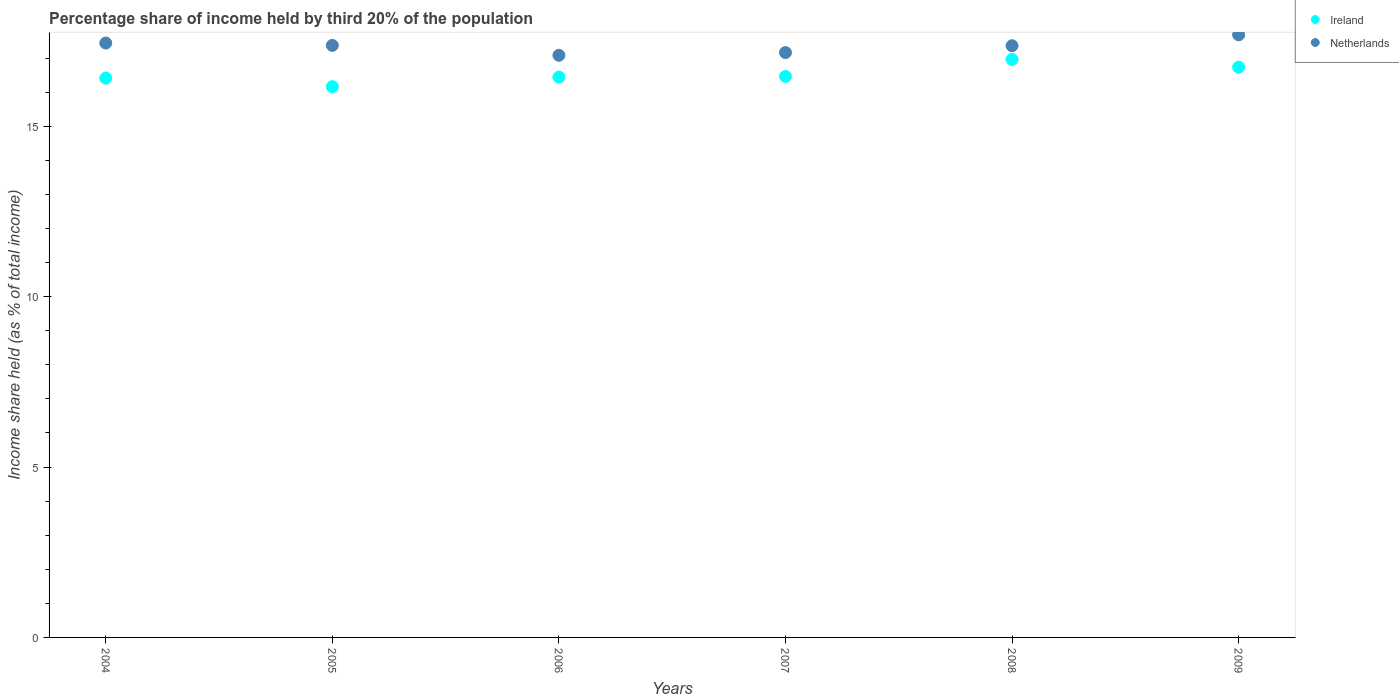How many different coloured dotlines are there?
Provide a short and direct response. 2. Is the number of dotlines equal to the number of legend labels?
Provide a short and direct response. Yes. What is the share of income held by third 20% of the population in Netherlands in 2008?
Ensure brevity in your answer.  17.36. Across all years, what is the maximum share of income held by third 20% of the population in Ireland?
Make the answer very short. 16.96. Across all years, what is the minimum share of income held by third 20% of the population in Netherlands?
Keep it short and to the point. 17.08. In which year was the share of income held by third 20% of the population in Ireland maximum?
Ensure brevity in your answer.  2008. In which year was the share of income held by third 20% of the population in Ireland minimum?
Provide a short and direct response. 2005. What is the total share of income held by third 20% of the population in Netherlands in the graph?
Offer a terse response. 104.09. What is the difference between the share of income held by third 20% of the population in Netherlands in 2006 and that in 2008?
Give a very brief answer. -0.28. What is the difference between the share of income held by third 20% of the population in Netherlands in 2005 and the share of income held by third 20% of the population in Ireland in 2009?
Your answer should be very brief. 0.64. What is the average share of income held by third 20% of the population in Netherlands per year?
Provide a short and direct response. 17.35. In the year 2004, what is the difference between the share of income held by third 20% of the population in Netherlands and share of income held by third 20% of the population in Ireland?
Your answer should be compact. 1.03. In how many years, is the share of income held by third 20% of the population in Ireland greater than 16 %?
Ensure brevity in your answer.  6. What is the ratio of the share of income held by third 20% of the population in Ireland in 2004 to that in 2007?
Your answer should be very brief. 1. Is the difference between the share of income held by third 20% of the population in Netherlands in 2006 and 2007 greater than the difference between the share of income held by third 20% of the population in Ireland in 2006 and 2007?
Make the answer very short. No. What is the difference between the highest and the second highest share of income held by third 20% of the population in Netherlands?
Your answer should be compact. 0.24. What is the difference between the highest and the lowest share of income held by third 20% of the population in Netherlands?
Make the answer very short. 0.6. Is the sum of the share of income held by third 20% of the population in Netherlands in 2005 and 2007 greater than the maximum share of income held by third 20% of the population in Ireland across all years?
Your answer should be very brief. Yes. Does the share of income held by third 20% of the population in Ireland monotonically increase over the years?
Give a very brief answer. No. Is the share of income held by third 20% of the population in Netherlands strictly less than the share of income held by third 20% of the population in Ireland over the years?
Ensure brevity in your answer.  No. How many dotlines are there?
Offer a very short reply. 2. How many years are there in the graph?
Your response must be concise. 6. What is the difference between two consecutive major ticks on the Y-axis?
Offer a terse response. 5. Does the graph contain grids?
Keep it short and to the point. No. How many legend labels are there?
Offer a terse response. 2. What is the title of the graph?
Ensure brevity in your answer.  Percentage share of income held by third 20% of the population. What is the label or title of the Y-axis?
Your answer should be very brief. Income share held (as % of total income). What is the Income share held (as % of total income) of Ireland in 2004?
Make the answer very short. 16.41. What is the Income share held (as % of total income) of Netherlands in 2004?
Your answer should be compact. 17.44. What is the Income share held (as % of total income) in Ireland in 2005?
Make the answer very short. 16.16. What is the Income share held (as % of total income) in Netherlands in 2005?
Keep it short and to the point. 17.37. What is the Income share held (as % of total income) of Ireland in 2006?
Offer a very short reply. 16.44. What is the Income share held (as % of total income) of Netherlands in 2006?
Offer a very short reply. 17.08. What is the Income share held (as % of total income) in Ireland in 2007?
Offer a very short reply. 16.46. What is the Income share held (as % of total income) in Netherlands in 2007?
Provide a short and direct response. 17.16. What is the Income share held (as % of total income) in Ireland in 2008?
Ensure brevity in your answer.  16.96. What is the Income share held (as % of total income) of Netherlands in 2008?
Your answer should be compact. 17.36. What is the Income share held (as % of total income) of Ireland in 2009?
Offer a terse response. 16.73. What is the Income share held (as % of total income) in Netherlands in 2009?
Offer a terse response. 17.68. Across all years, what is the maximum Income share held (as % of total income) in Ireland?
Keep it short and to the point. 16.96. Across all years, what is the maximum Income share held (as % of total income) in Netherlands?
Keep it short and to the point. 17.68. Across all years, what is the minimum Income share held (as % of total income) in Ireland?
Your response must be concise. 16.16. Across all years, what is the minimum Income share held (as % of total income) in Netherlands?
Give a very brief answer. 17.08. What is the total Income share held (as % of total income) in Ireland in the graph?
Offer a terse response. 99.16. What is the total Income share held (as % of total income) of Netherlands in the graph?
Your response must be concise. 104.09. What is the difference between the Income share held (as % of total income) of Ireland in 2004 and that in 2005?
Your response must be concise. 0.25. What is the difference between the Income share held (as % of total income) of Netherlands in 2004 and that in 2005?
Offer a terse response. 0.07. What is the difference between the Income share held (as % of total income) of Ireland in 2004 and that in 2006?
Your answer should be very brief. -0.03. What is the difference between the Income share held (as % of total income) in Netherlands in 2004 and that in 2006?
Keep it short and to the point. 0.36. What is the difference between the Income share held (as % of total income) of Netherlands in 2004 and that in 2007?
Offer a very short reply. 0.28. What is the difference between the Income share held (as % of total income) of Ireland in 2004 and that in 2008?
Ensure brevity in your answer.  -0.55. What is the difference between the Income share held (as % of total income) of Netherlands in 2004 and that in 2008?
Give a very brief answer. 0.08. What is the difference between the Income share held (as % of total income) of Ireland in 2004 and that in 2009?
Your answer should be very brief. -0.32. What is the difference between the Income share held (as % of total income) in Netherlands in 2004 and that in 2009?
Ensure brevity in your answer.  -0.24. What is the difference between the Income share held (as % of total income) of Ireland in 2005 and that in 2006?
Your response must be concise. -0.28. What is the difference between the Income share held (as % of total income) of Netherlands in 2005 and that in 2006?
Your answer should be very brief. 0.29. What is the difference between the Income share held (as % of total income) of Netherlands in 2005 and that in 2007?
Ensure brevity in your answer.  0.21. What is the difference between the Income share held (as % of total income) of Netherlands in 2005 and that in 2008?
Your response must be concise. 0.01. What is the difference between the Income share held (as % of total income) in Ireland in 2005 and that in 2009?
Keep it short and to the point. -0.57. What is the difference between the Income share held (as % of total income) in Netherlands in 2005 and that in 2009?
Your answer should be compact. -0.31. What is the difference between the Income share held (as % of total income) in Ireland in 2006 and that in 2007?
Provide a succinct answer. -0.02. What is the difference between the Income share held (as % of total income) in Netherlands in 2006 and that in 2007?
Provide a succinct answer. -0.08. What is the difference between the Income share held (as % of total income) of Ireland in 2006 and that in 2008?
Give a very brief answer. -0.52. What is the difference between the Income share held (as % of total income) in Netherlands in 2006 and that in 2008?
Offer a very short reply. -0.28. What is the difference between the Income share held (as % of total income) of Ireland in 2006 and that in 2009?
Make the answer very short. -0.29. What is the difference between the Income share held (as % of total income) in Netherlands in 2006 and that in 2009?
Ensure brevity in your answer.  -0.6. What is the difference between the Income share held (as % of total income) in Ireland in 2007 and that in 2008?
Ensure brevity in your answer.  -0.5. What is the difference between the Income share held (as % of total income) in Ireland in 2007 and that in 2009?
Your response must be concise. -0.27. What is the difference between the Income share held (as % of total income) in Netherlands in 2007 and that in 2009?
Your answer should be very brief. -0.52. What is the difference between the Income share held (as % of total income) in Ireland in 2008 and that in 2009?
Make the answer very short. 0.23. What is the difference between the Income share held (as % of total income) of Netherlands in 2008 and that in 2009?
Provide a succinct answer. -0.32. What is the difference between the Income share held (as % of total income) of Ireland in 2004 and the Income share held (as % of total income) of Netherlands in 2005?
Your response must be concise. -0.96. What is the difference between the Income share held (as % of total income) of Ireland in 2004 and the Income share held (as % of total income) of Netherlands in 2006?
Provide a succinct answer. -0.67. What is the difference between the Income share held (as % of total income) of Ireland in 2004 and the Income share held (as % of total income) of Netherlands in 2007?
Your answer should be very brief. -0.75. What is the difference between the Income share held (as % of total income) of Ireland in 2004 and the Income share held (as % of total income) of Netherlands in 2008?
Offer a very short reply. -0.95. What is the difference between the Income share held (as % of total income) in Ireland in 2004 and the Income share held (as % of total income) in Netherlands in 2009?
Offer a terse response. -1.27. What is the difference between the Income share held (as % of total income) in Ireland in 2005 and the Income share held (as % of total income) in Netherlands in 2006?
Your answer should be compact. -0.92. What is the difference between the Income share held (as % of total income) of Ireland in 2005 and the Income share held (as % of total income) of Netherlands in 2009?
Your response must be concise. -1.52. What is the difference between the Income share held (as % of total income) of Ireland in 2006 and the Income share held (as % of total income) of Netherlands in 2007?
Your answer should be very brief. -0.72. What is the difference between the Income share held (as % of total income) of Ireland in 2006 and the Income share held (as % of total income) of Netherlands in 2008?
Give a very brief answer. -0.92. What is the difference between the Income share held (as % of total income) in Ireland in 2006 and the Income share held (as % of total income) in Netherlands in 2009?
Your answer should be very brief. -1.24. What is the difference between the Income share held (as % of total income) in Ireland in 2007 and the Income share held (as % of total income) in Netherlands in 2008?
Provide a succinct answer. -0.9. What is the difference between the Income share held (as % of total income) in Ireland in 2007 and the Income share held (as % of total income) in Netherlands in 2009?
Your answer should be very brief. -1.22. What is the difference between the Income share held (as % of total income) in Ireland in 2008 and the Income share held (as % of total income) in Netherlands in 2009?
Keep it short and to the point. -0.72. What is the average Income share held (as % of total income) of Ireland per year?
Make the answer very short. 16.53. What is the average Income share held (as % of total income) of Netherlands per year?
Your response must be concise. 17.35. In the year 2004, what is the difference between the Income share held (as % of total income) in Ireland and Income share held (as % of total income) in Netherlands?
Provide a short and direct response. -1.03. In the year 2005, what is the difference between the Income share held (as % of total income) of Ireland and Income share held (as % of total income) of Netherlands?
Keep it short and to the point. -1.21. In the year 2006, what is the difference between the Income share held (as % of total income) of Ireland and Income share held (as % of total income) of Netherlands?
Provide a short and direct response. -0.64. In the year 2007, what is the difference between the Income share held (as % of total income) in Ireland and Income share held (as % of total income) in Netherlands?
Offer a terse response. -0.7. In the year 2009, what is the difference between the Income share held (as % of total income) of Ireland and Income share held (as % of total income) of Netherlands?
Offer a very short reply. -0.95. What is the ratio of the Income share held (as % of total income) of Ireland in 2004 to that in 2005?
Ensure brevity in your answer.  1.02. What is the ratio of the Income share held (as % of total income) of Netherlands in 2004 to that in 2005?
Offer a very short reply. 1. What is the ratio of the Income share held (as % of total income) in Ireland in 2004 to that in 2006?
Provide a short and direct response. 1. What is the ratio of the Income share held (as % of total income) in Netherlands in 2004 to that in 2006?
Keep it short and to the point. 1.02. What is the ratio of the Income share held (as % of total income) in Ireland in 2004 to that in 2007?
Give a very brief answer. 1. What is the ratio of the Income share held (as % of total income) of Netherlands in 2004 to that in 2007?
Provide a short and direct response. 1.02. What is the ratio of the Income share held (as % of total income) in Ireland in 2004 to that in 2008?
Offer a terse response. 0.97. What is the ratio of the Income share held (as % of total income) in Ireland in 2004 to that in 2009?
Provide a succinct answer. 0.98. What is the ratio of the Income share held (as % of total income) of Netherlands in 2004 to that in 2009?
Your response must be concise. 0.99. What is the ratio of the Income share held (as % of total income) of Netherlands in 2005 to that in 2006?
Offer a very short reply. 1.02. What is the ratio of the Income share held (as % of total income) in Ireland in 2005 to that in 2007?
Provide a short and direct response. 0.98. What is the ratio of the Income share held (as % of total income) in Netherlands in 2005 to that in 2007?
Provide a short and direct response. 1.01. What is the ratio of the Income share held (as % of total income) in Ireland in 2005 to that in 2008?
Keep it short and to the point. 0.95. What is the ratio of the Income share held (as % of total income) in Netherlands in 2005 to that in 2008?
Your answer should be compact. 1. What is the ratio of the Income share held (as % of total income) of Ireland in 2005 to that in 2009?
Give a very brief answer. 0.97. What is the ratio of the Income share held (as % of total income) of Netherlands in 2005 to that in 2009?
Give a very brief answer. 0.98. What is the ratio of the Income share held (as % of total income) in Ireland in 2006 to that in 2007?
Your answer should be very brief. 1. What is the ratio of the Income share held (as % of total income) in Netherlands in 2006 to that in 2007?
Make the answer very short. 1. What is the ratio of the Income share held (as % of total income) of Ireland in 2006 to that in 2008?
Provide a succinct answer. 0.97. What is the ratio of the Income share held (as % of total income) of Netherlands in 2006 to that in 2008?
Give a very brief answer. 0.98. What is the ratio of the Income share held (as % of total income) of Ireland in 2006 to that in 2009?
Provide a short and direct response. 0.98. What is the ratio of the Income share held (as % of total income) in Netherlands in 2006 to that in 2009?
Offer a terse response. 0.97. What is the ratio of the Income share held (as % of total income) in Ireland in 2007 to that in 2008?
Give a very brief answer. 0.97. What is the ratio of the Income share held (as % of total income) of Netherlands in 2007 to that in 2008?
Keep it short and to the point. 0.99. What is the ratio of the Income share held (as % of total income) of Ireland in 2007 to that in 2009?
Your answer should be very brief. 0.98. What is the ratio of the Income share held (as % of total income) of Netherlands in 2007 to that in 2009?
Your response must be concise. 0.97. What is the ratio of the Income share held (as % of total income) of Ireland in 2008 to that in 2009?
Provide a short and direct response. 1.01. What is the ratio of the Income share held (as % of total income) of Netherlands in 2008 to that in 2009?
Make the answer very short. 0.98. What is the difference between the highest and the second highest Income share held (as % of total income) in Ireland?
Your response must be concise. 0.23. What is the difference between the highest and the second highest Income share held (as % of total income) of Netherlands?
Your answer should be very brief. 0.24. What is the difference between the highest and the lowest Income share held (as % of total income) in Ireland?
Ensure brevity in your answer.  0.8. 